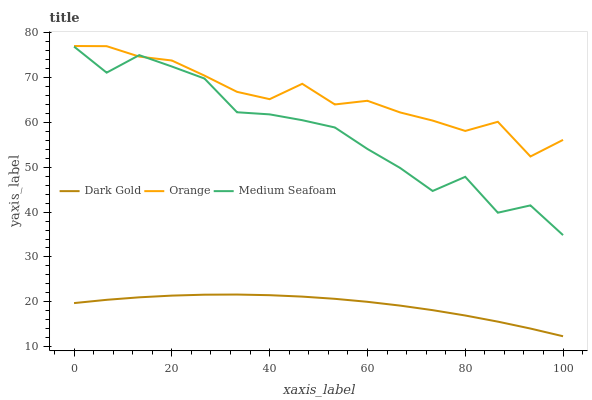Does Dark Gold have the minimum area under the curve?
Answer yes or no. Yes. Does Orange have the maximum area under the curve?
Answer yes or no. Yes. Does Medium Seafoam have the minimum area under the curve?
Answer yes or no. No. Does Medium Seafoam have the maximum area under the curve?
Answer yes or no. No. Is Dark Gold the smoothest?
Answer yes or no. Yes. Is Medium Seafoam the roughest?
Answer yes or no. Yes. Is Medium Seafoam the smoothest?
Answer yes or no. No. Is Dark Gold the roughest?
Answer yes or no. No. Does Dark Gold have the lowest value?
Answer yes or no. Yes. Does Medium Seafoam have the lowest value?
Answer yes or no. No. Does Orange have the highest value?
Answer yes or no. Yes. Does Medium Seafoam have the highest value?
Answer yes or no. No. Is Dark Gold less than Medium Seafoam?
Answer yes or no. Yes. Is Orange greater than Dark Gold?
Answer yes or no. Yes. Does Orange intersect Medium Seafoam?
Answer yes or no. Yes. Is Orange less than Medium Seafoam?
Answer yes or no. No. Is Orange greater than Medium Seafoam?
Answer yes or no. No. Does Dark Gold intersect Medium Seafoam?
Answer yes or no. No. 